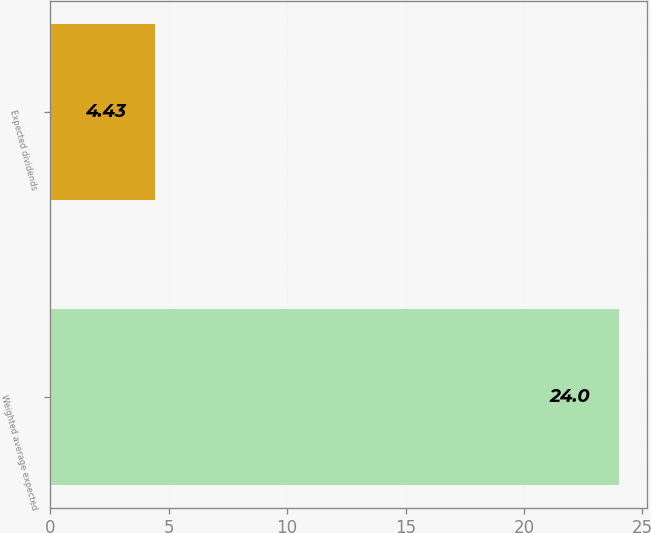Convert chart to OTSL. <chart><loc_0><loc_0><loc_500><loc_500><bar_chart><fcel>Weighted average expected<fcel>Expected dividends<nl><fcel>24<fcel>4.43<nl></chart> 